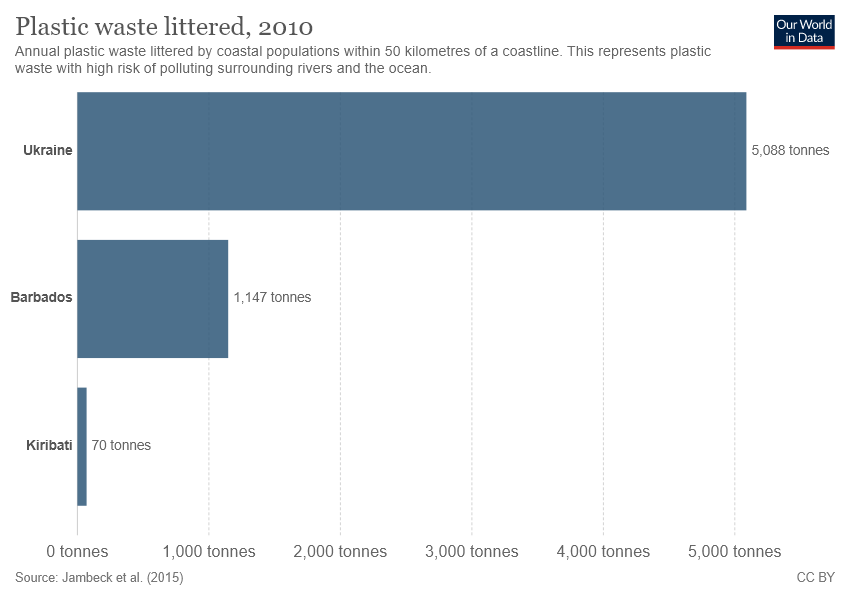Identify some key points in this picture. According to the provided data, the total tonnage for Ukraine and Barbados is 6,235. The color of all bars is blue. 